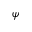<formula> <loc_0><loc_0><loc_500><loc_500>\psi</formula> 